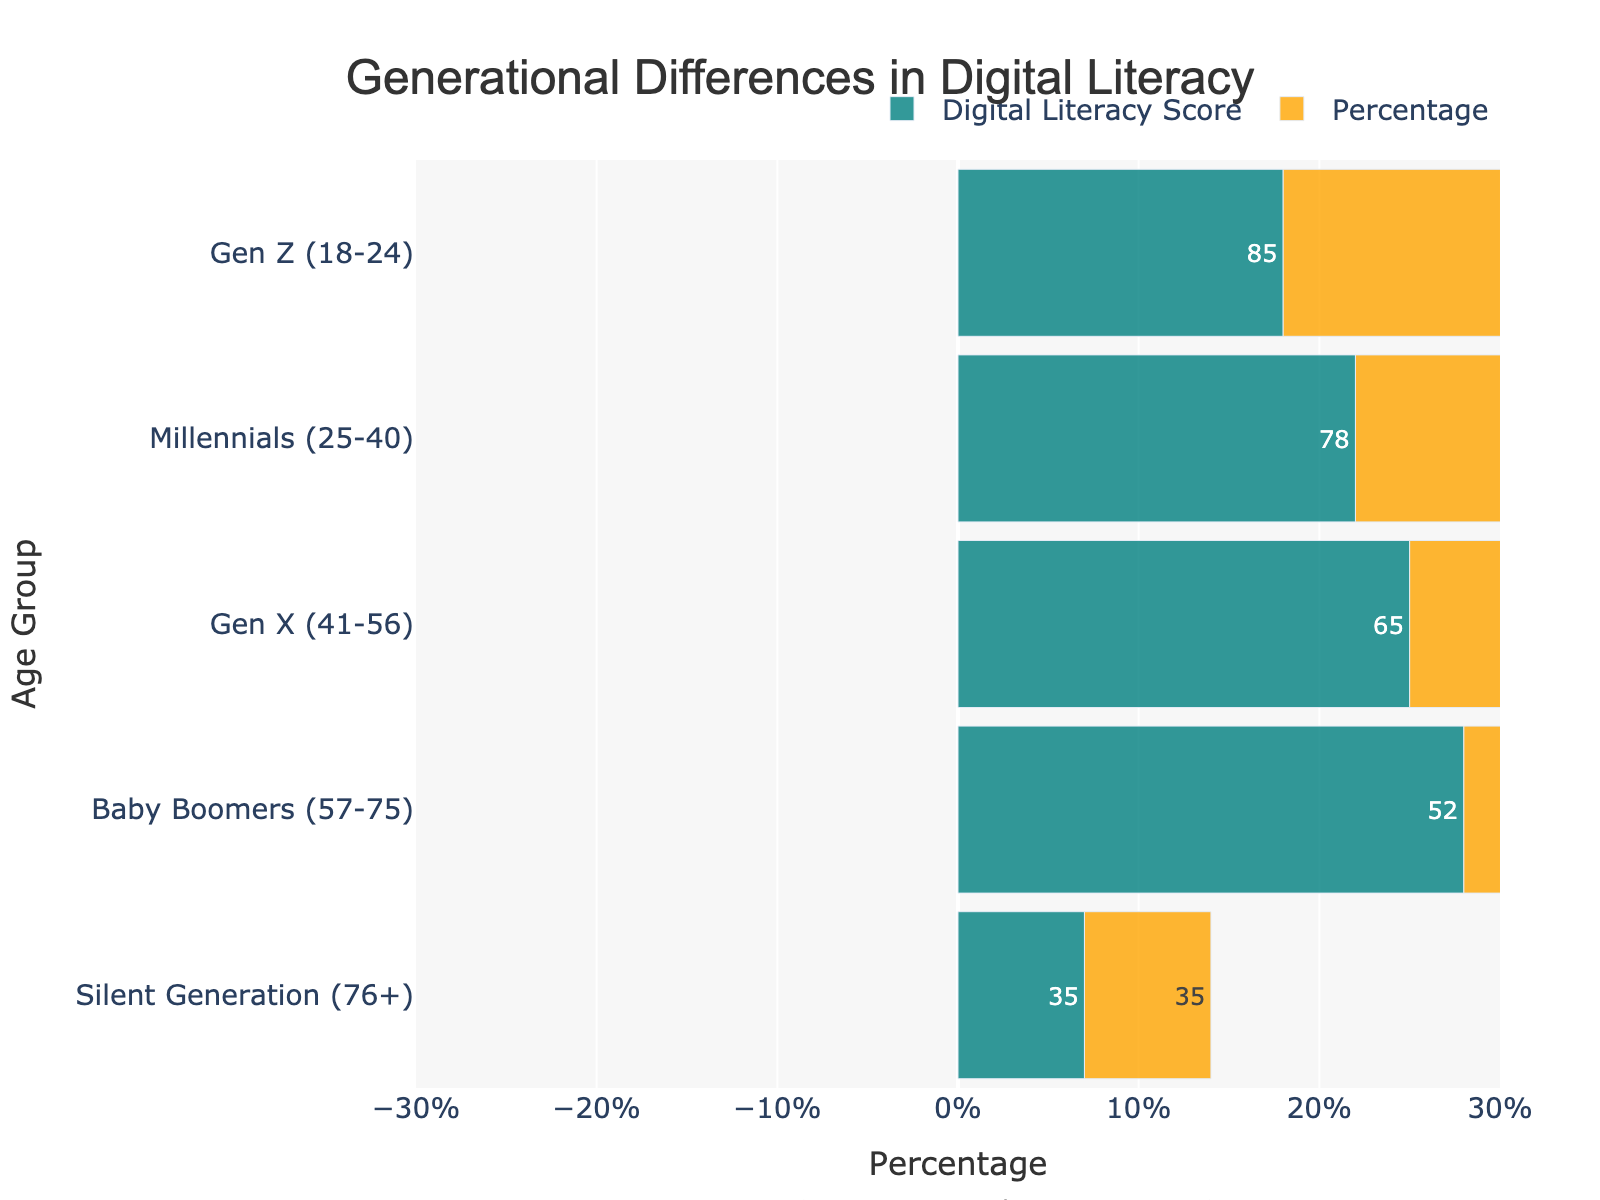What is the title of the figure? The title of the figure is located at the top and reads "Generational Differences in Digital Literacy".
Answer: Generational Differences in Digital Literacy Which age group has the highest digital literacy score? The positive bar sections show the digital literacy score, and Gen Z (18-24) has the highest score indicated by a value of 85.
Answer: Gen Z (18-24) Which age group has the lowest digital literacy score? The positive bar sections indicate the digital literacy score, and the Silent Generation (76+) has the lowest score at 35.
Answer: Silent Generation (76+) What percentage of Baby Boomers is represented in the chart? The chart shows that the Baby Boomers (57-75) have a bar stretching to 28% on both sides.
Answer: 28% How do the digital literacy scores of Millennials compare to Baby Boomers? Millennials (25-40) have a digital literacy score of 78, while Baby Boomers (57-75) have a score of 52. 78 is greater than 52.
Answer: Millennials have a higher score What is the total percentage of volunteers aged 41 or older? Add the percentages of Gen X (41-56), Baby Boomers (57-75), and Silent Generation (76+), which are 25 + 28 + 7 = 60%.
Answer: 60% What is the average digital literacy score among Gen Z, Millennials, and Gen X? Add the scores of Gen Z (85), Millennials (78), and Gen X (65) and divide by 3. (85 + 78 + 65) / 3 = 76.
Answer: 76 Which generation has the closest average digital literacy to the overall average? The overall average score of all generations is calculated by adding all scores and dividing by 5: (85 + 78 + 65 + 52 + 35) / 5 = 63. Millennials at 78 are closer to this average than other generations.
Answer: Millennials What digital literacy score is displayed inside the Gen X bar on the figure? Inside the Gen X (41-56) bar, the score displayed is 65.
Answer: 65 How much lower is the Silent Generation's digital literacy score compared to Gen X? Subtract the Silent Generation's score (35) from Gen X's score (65). The difference is 65 - 35 = 30.
Answer: 30 